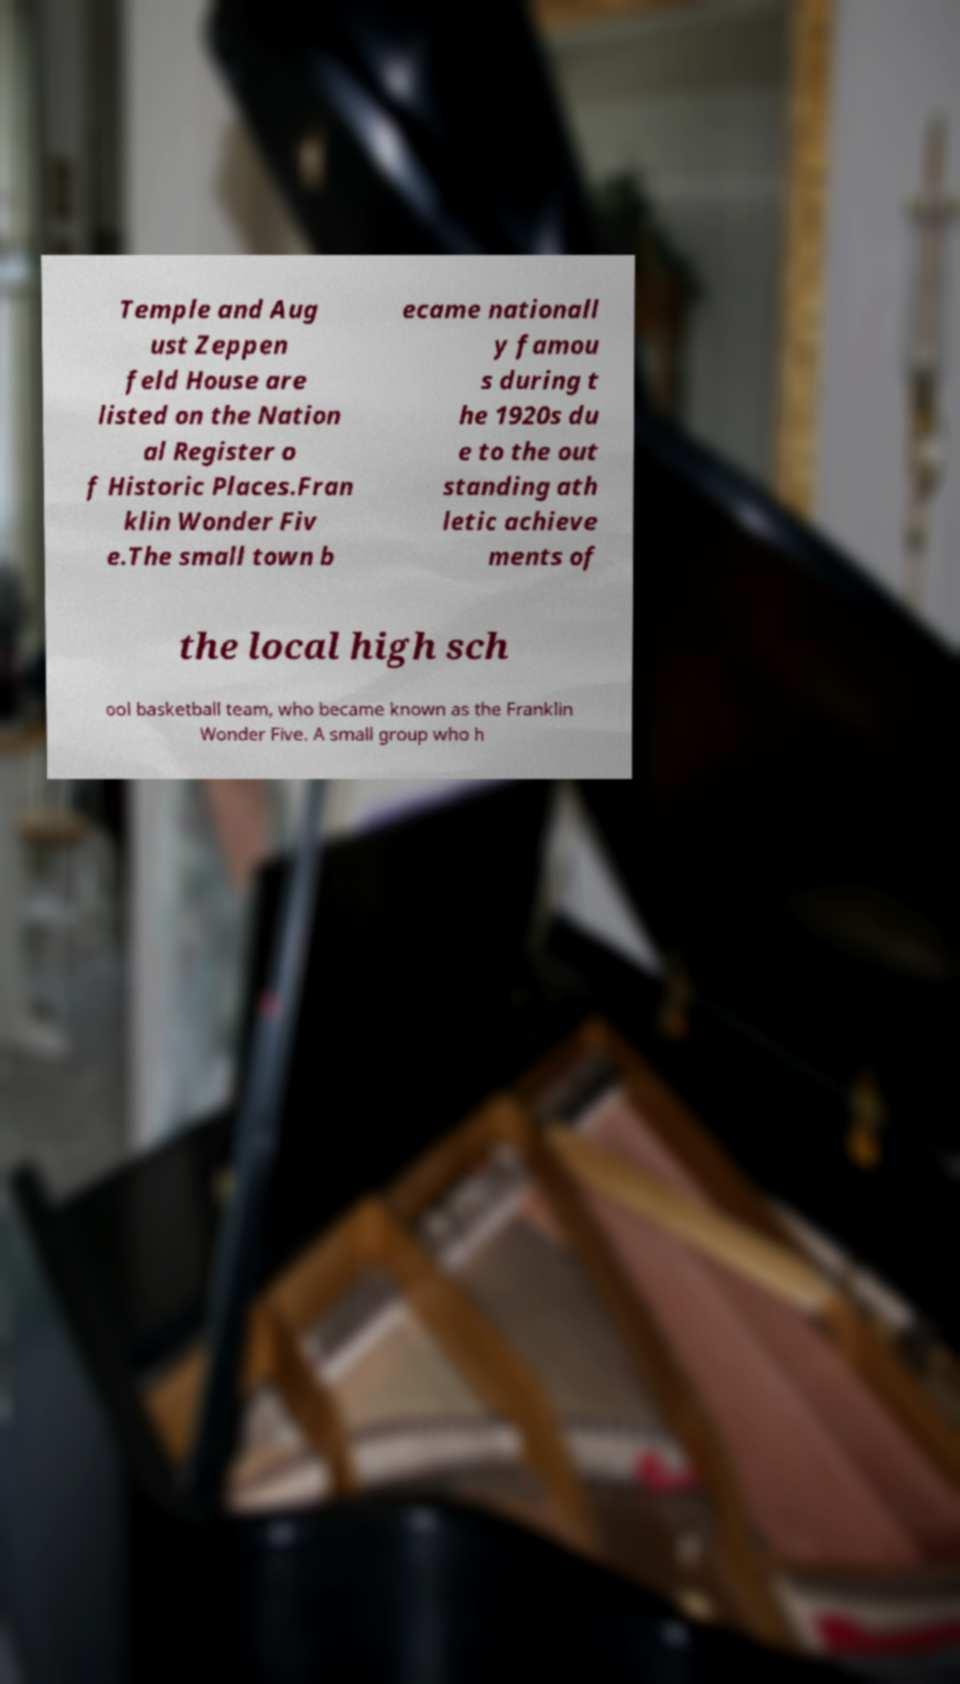Please read and relay the text visible in this image. What does it say? Temple and Aug ust Zeppen feld House are listed on the Nation al Register o f Historic Places.Fran klin Wonder Fiv e.The small town b ecame nationall y famou s during t he 1920s du e to the out standing ath letic achieve ments of the local high sch ool basketball team, who became known as the Franklin Wonder Five. A small group who h 